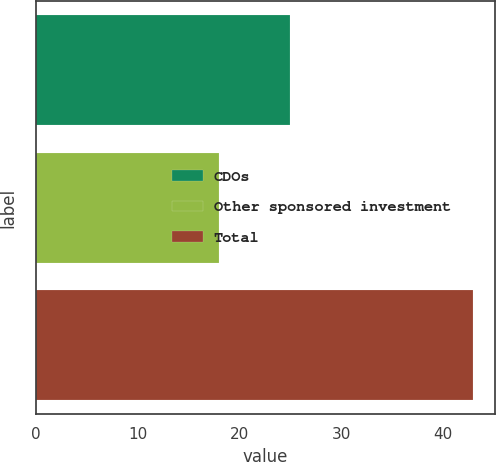<chart> <loc_0><loc_0><loc_500><loc_500><bar_chart><fcel>CDOs<fcel>Other sponsored investment<fcel>Total<nl><fcel>25<fcel>18<fcel>43<nl></chart> 